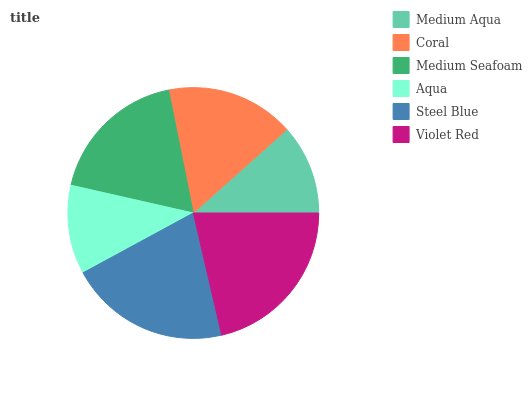Is Aqua the minimum?
Answer yes or no. Yes. Is Violet Red the maximum?
Answer yes or no. Yes. Is Coral the minimum?
Answer yes or no. No. Is Coral the maximum?
Answer yes or no. No. Is Coral greater than Medium Aqua?
Answer yes or no. Yes. Is Medium Aqua less than Coral?
Answer yes or no. Yes. Is Medium Aqua greater than Coral?
Answer yes or no. No. Is Coral less than Medium Aqua?
Answer yes or no. No. Is Medium Seafoam the high median?
Answer yes or no. Yes. Is Coral the low median?
Answer yes or no. Yes. Is Violet Red the high median?
Answer yes or no. No. Is Steel Blue the low median?
Answer yes or no. No. 